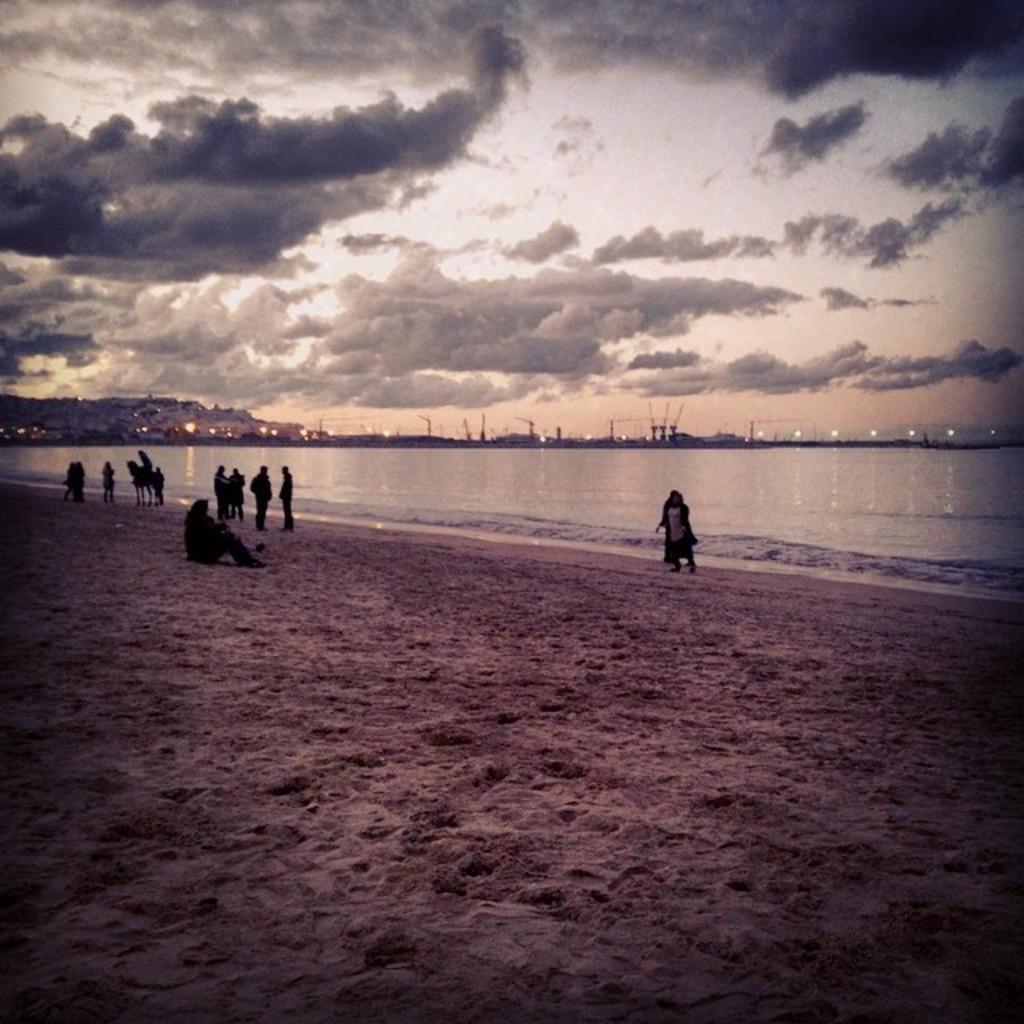Please provide a concise description of this image. In this image I can see few people,water,mountains,poles and lights. The sky is cloudy. 